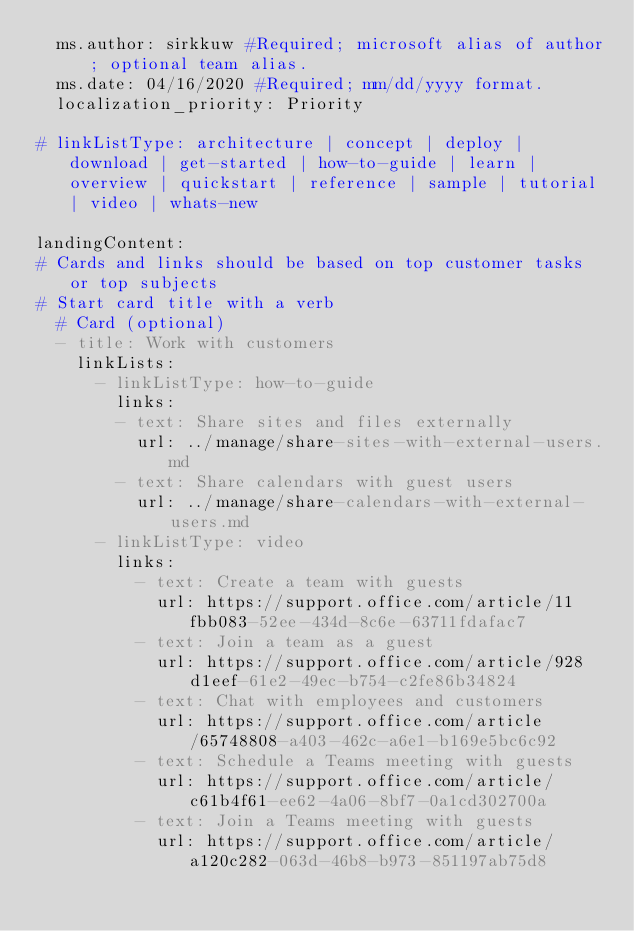Convert code to text. <code><loc_0><loc_0><loc_500><loc_500><_YAML_>  ms.author: sirkkuw #Required; microsoft alias of author; optional team alias.
  ms.date: 04/16/2020 #Required; mm/dd/yyyy format.
  localization_priority: Priority

# linkListType: architecture | concept | deploy | download | get-started | how-to-guide | learn | overview | quickstart | reference | sample | tutorial | video | whats-new

landingContent:
# Cards and links should be based on top customer tasks or top subjects
# Start card title with a verb
  # Card (optional)
  - title: Work with customers
    linkLists:
      - linkListType: how-to-guide
        links:
        - text: Share sites and files externally
          url: ../manage/share-sites-with-external-users.md
        - text: Share calendars with guest users
          url: ../manage/share-calendars-with-external-users.md
      - linkListType: video
        links:
          - text: Create a team with guests
            url: https://support.office.com/article/11fbb083-52ee-434d-8c6e-63711fdafac7
          - text: Join a team as a guest
            url: https://support.office.com/article/928d1eef-61e2-49ec-b754-c2fe86b34824
          - text: Chat with employees and customers
            url: https://support.office.com/article/65748808-a403-462c-a6e1-b169e5bc6c92
          - text: Schedule a Teams meeting with guests
            url: https://support.office.com/article/c61b4f61-ee62-4a06-8bf7-0a1cd302700a
          - text: Join a Teams meeting with guests
            url: https://support.office.com/article/a120c282-063d-46b8-b973-851197ab75d8</code> 